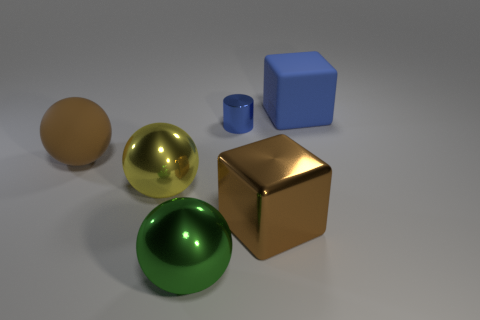Subtract all metal spheres. How many spheres are left? 1 Add 2 small things. How many objects exist? 8 Subtract 1 spheres. How many spheres are left? 2 Subtract all cylinders. How many objects are left? 5 Subtract all cyan spheres. Subtract all cyan cylinders. How many spheres are left? 3 Subtract all small cyan shiny spheres. Subtract all big brown blocks. How many objects are left? 5 Add 6 blue rubber blocks. How many blue rubber blocks are left? 7 Add 6 small gray shiny cylinders. How many small gray shiny cylinders exist? 6 Subtract 0 brown cylinders. How many objects are left? 6 